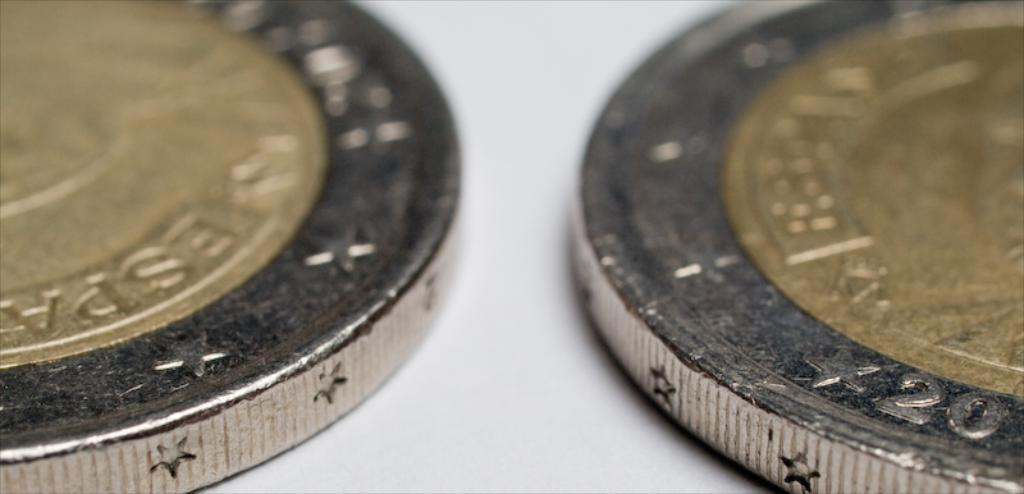<image>
Present a compact description of the photo's key features. the number 20 is on the coin that is next to another one 